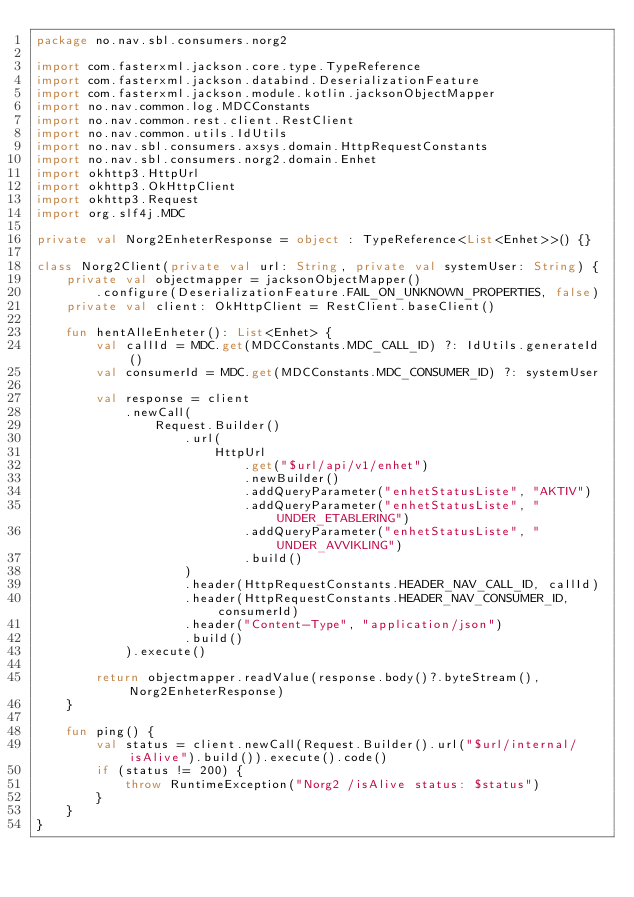Convert code to text. <code><loc_0><loc_0><loc_500><loc_500><_Kotlin_>package no.nav.sbl.consumers.norg2

import com.fasterxml.jackson.core.type.TypeReference
import com.fasterxml.jackson.databind.DeserializationFeature
import com.fasterxml.jackson.module.kotlin.jacksonObjectMapper
import no.nav.common.log.MDCConstants
import no.nav.common.rest.client.RestClient
import no.nav.common.utils.IdUtils
import no.nav.sbl.consumers.axsys.domain.HttpRequestConstants
import no.nav.sbl.consumers.norg2.domain.Enhet
import okhttp3.HttpUrl
import okhttp3.OkHttpClient
import okhttp3.Request
import org.slf4j.MDC

private val Norg2EnheterResponse = object : TypeReference<List<Enhet>>() {}

class Norg2Client(private val url: String, private val systemUser: String) {
    private val objectmapper = jacksonObjectMapper()
        .configure(DeserializationFeature.FAIL_ON_UNKNOWN_PROPERTIES, false)
    private val client: OkHttpClient = RestClient.baseClient()

    fun hentAlleEnheter(): List<Enhet> {
        val callId = MDC.get(MDCConstants.MDC_CALL_ID) ?: IdUtils.generateId()
        val consumerId = MDC.get(MDCConstants.MDC_CONSUMER_ID) ?: systemUser

        val response = client
            .newCall(
                Request.Builder()
                    .url(
                        HttpUrl
                            .get("$url/api/v1/enhet")
                            .newBuilder()
                            .addQueryParameter("enhetStatusListe", "AKTIV")
                            .addQueryParameter("enhetStatusListe", "UNDER_ETABLERING")
                            .addQueryParameter("enhetStatusListe", "UNDER_AVVIKLING")
                            .build()
                    )
                    .header(HttpRequestConstants.HEADER_NAV_CALL_ID, callId)
                    .header(HttpRequestConstants.HEADER_NAV_CONSUMER_ID, consumerId)
                    .header("Content-Type", "application/json")
                    .build()
            ).execute()

        return objectmapper.readValue(response.body()?.byteStream(), Norg2EnheterResponse)
    }

    fun ping() {
        val status = client.newCall(Request.Builder().url("$url/internal/isAlive").build()).execute().code()
        if (status != 200) {
            throw RuntimeException("Norg2 /isAlive status: $status")
        }
    }
}
</code> 